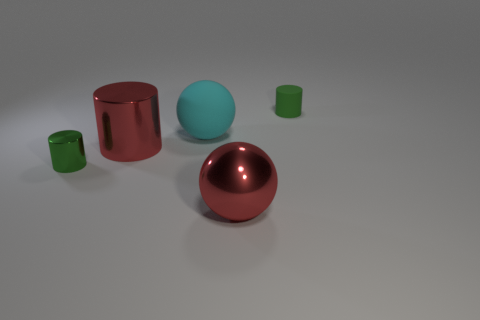Add 2 small green metallic objects. How many objects exist? 7 Subtract all spheres. How many objects are left? 3 Subtract 0 purple spheres. How many objects are left? 5 Subtract all tiny rubber cylinders. Subtract all large blue metallic cylinders. How many objects are left? 4 Add 5 cyan balls. How many cyan balls are left? 6 Add 1 metal cylinders. How many metal cylinders exist? 3 